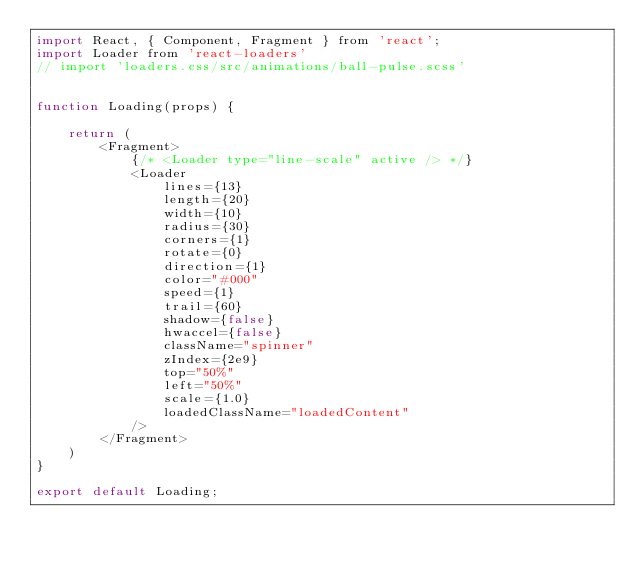Convert code to text. <code><loc_0><loc_0><loc_500><loc_500><_JavaScript_>import React, { Component, Fragment } from 'react';
import Loader from 'react-loaders'
// import 'loaders.css/src/animations/ball-pulse.scss'


function Loading(props) {

    return (
        <Fragment>
            {/* <Loader type="line-scale" active /> */}
            <Loader
                lines={13}
                length={20}
                width={10}
                radius={30}
                corners={1}
                rotate={0}
                direction={1}
                color="#000"
                speed={1}
                trail={60}
                shadow={false}
                hwaccel={false}
                className="spinner"
                zIndex={2e9}
                top="50%"
                left="50%"
                scale={1.0}
                loadedClassName="loadedContent"
            />
        </Fragment>
    )
}

export default Loading;
</code> 